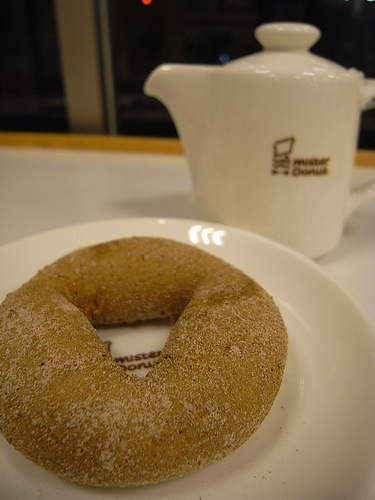Describe the objects in this image and their specific colors. I can see dining table in tan, black, and olive tones and donut in black, olive, and maroon tones in this image. 